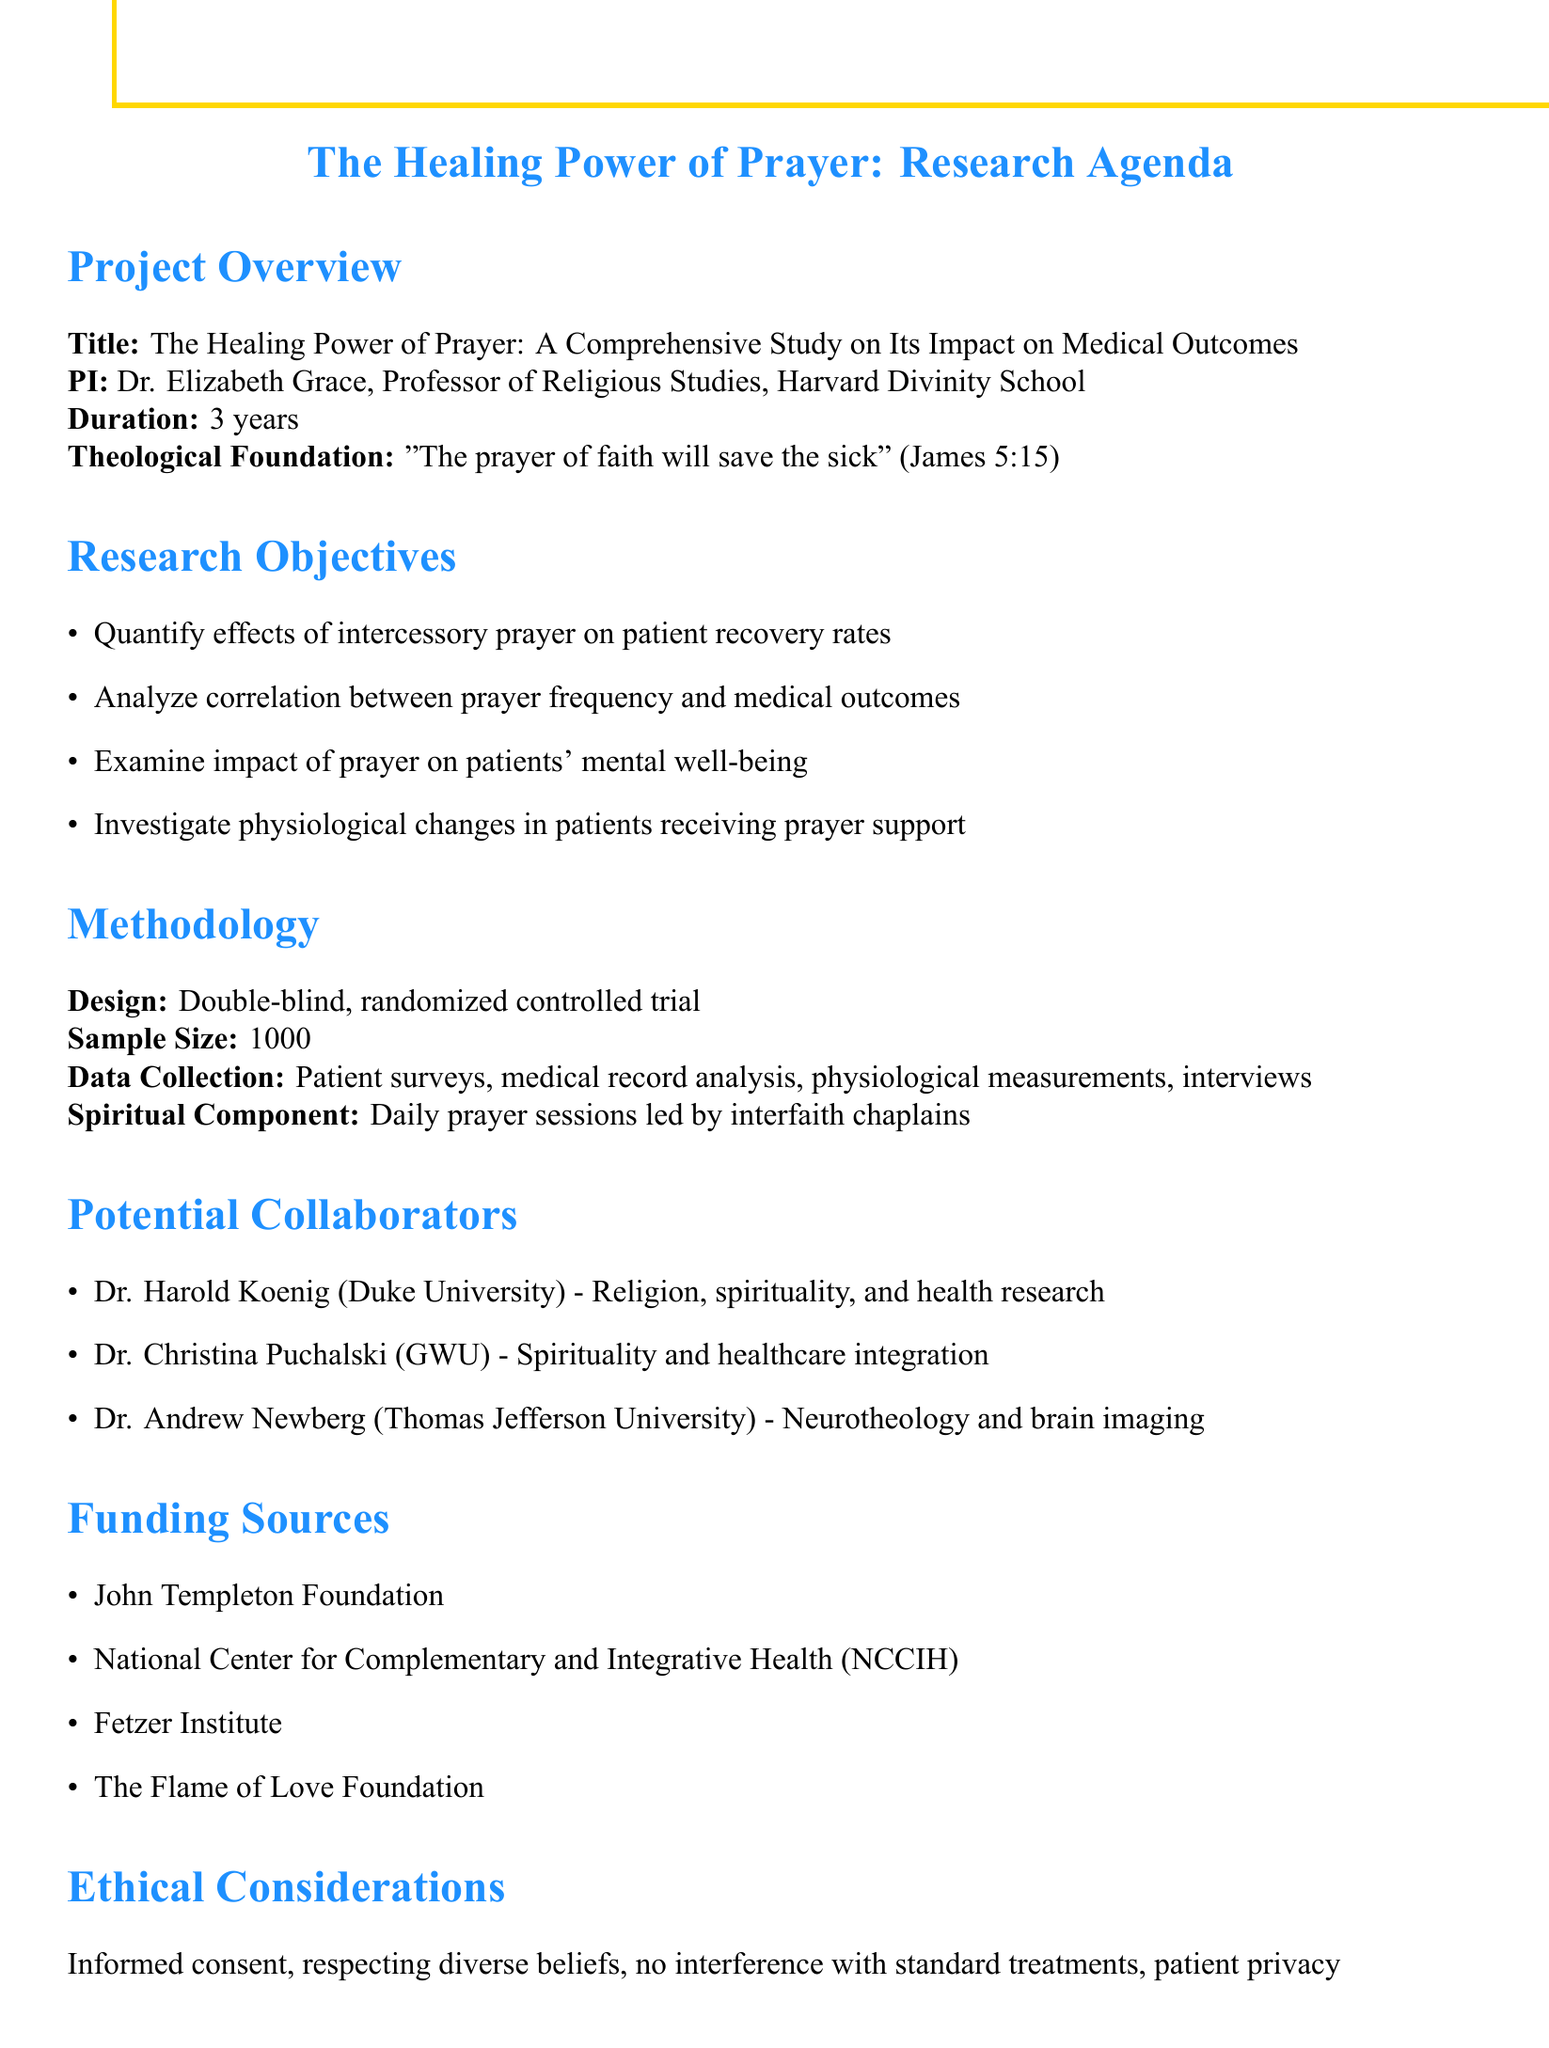What is the title of the research project? The title is mentioned in the project overview section, which provides a brief description of the study.
Answer: The Healing Power of Prayer: A Comprehensive Study on Its Impact on Medical Outcomes Who is the principal investigator of the study? The principal investigator's name and affiliation are listed in the project overview section along with their title.
Answer: Dr. Elizabeth Grace What is the duration of the research project? The duration of the project is specified in the project overview section.
Answer: 3 years How many participants are included in the sample size? The sample size is stated in the methodology section, indicating how many subjects will be involved in the study.
Answer: 1000 What ethical consideration involves securing agreement from patients? This ethical consideration is stated in the ethical considerations section, which highlights the importance of patient rights and consent.
Answer: Obtaining informed consent from patients Name one potential collaborator and their area of expertise. One collaborator, along with their area of expertise, is listed in the potential collaborators section.
Answer: Dr. Harold Koenig, Religion, spirituality, and health research What type of study design is being utilized? The study design is outlined in the methodology section, detailing the research framework.
Answer: Double-blind, randomized controlled trial Which funding source focuses on faith-based medical research? This funding source is identified in the funding sources section, providing options for financial support.
Answer: The Flame of Love Foundation What is one expected outcome from the research project? The expected outcomes are outlined in a list, detailing the anticipated results of the study.
Answer: Statistically significant correlation between prayer and improved medical outcomes 